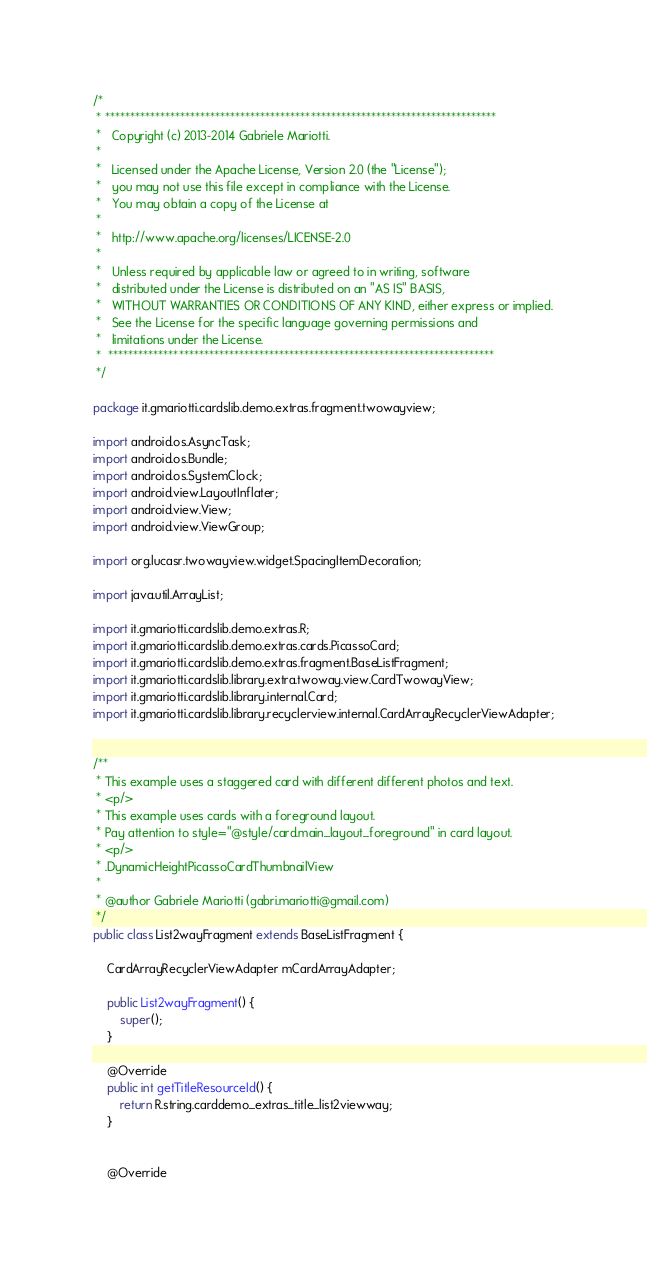Convert code to text. <code><loc_0><loc_0><loc_500><loc_500><_Java_>/*
 * ******************************************************************************
 *   Copyright (c) 2013-2014 Gabriele Mariotti.
 *
 *   Licensed under the Apache License, Version 2.0 (the "License");
 *   you may not use this file except in compliance with the License.
 *   You may obtain a copy of the License at
 *
 *   http://www.apache.org/licenses/LICENSE-2.0
 *
 *   Unless required by applicable law or agreed to in writing, software
 *   distributed under the License is distributed on an "AS IS" BASIS,
 *   WITHOUT WARRANTIES OR CONDITIONS OF ANY KIND, either express or implied.
 *   See the License for the specific language governing permissions and
 *   limitations under the License.
 *  *****************************************************************************
 */

package it.gmariotti.cardslib.demo.extras.fragment.twowayview;

import android.os.AsyncTask;
import android.os.Bundle;
import android.os.SystemClock;
import android.view.LayoutInflater;
import android.view.View;
import android.view.ViewGroup;

import org.lucasr.twowayview.widget.SpacingItemDecoration;

import java.util.ArrayList;

import it.gmariotti.cardslib.demo.extras.R;
import it.gmariotti.cardslib.demo.extras.cards.PicassoCard;
import it.gmariotti.cardslib.demo.extras.fragment.BaseListFragment;
import it.gmariotti.cardslib.library.extra.twoway.view.CardTwowayView;
import it.gmariotti.cardslib.library.internal.Card;
import it.gmariotti.cardslib.library.recyclerview.internal.CardArrayRecyclerViewAdapter;


/**
 * This example uses a staggered card with different different photos and text.
 * <p/>
 * This example uses cards with a foreground layout.
 * Pay attention to style="@style/card.main_layout_foreground" in card layout.
 * <p/>
 * .DynamicHeightPicassoCardThumbnailView
 *
 * @author Gabriele Mariotti (gabri.mariotti@gmail.com)
 */
public class List2wayFragment extends BaseListFragment {

    CardArrayRecyclerViewAdapter mCardArrayAdapter;

    public List2wayFragment() {
        super();
    }

    @Override
    public int getTitleResourceId() {
        return R.string.carddemo_extras_title_list2viewway;
    }


    @Override</code> 